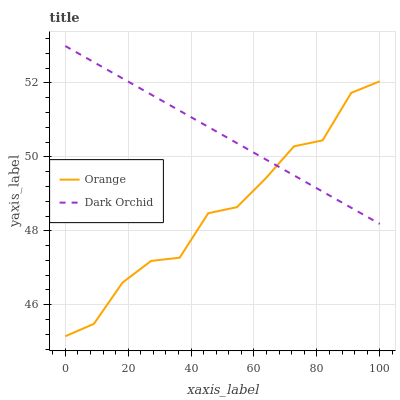Does Orange have the minimum area under the curve?
Answer yes or no. Yes. Does Dark Orchid have the maximum area under the curve?
Answer yes or no. Yes. Does Dark Orchid have the minimum area under the curve?
Answer yes or no. No. Is Dark Orchid the smoothest?
Answer yes or no. Yes. Is Orange the roughest?
Answer yes or no. Yes. Is Dark Orchid the roughest?
Answer yes or no. No. Does Dark Orchid have the lowest value?
Answer yes or no. No. Does Dark Orchid have the highest value?
Answer yes or no. Yes. Does Orange intersect Dark Orchid?
Answer yes or no. Yes. Is Orange less than Dark Orchid?
Answer yes or no. No. Is Orange greater than Dark Orchid?
Answer yes or no. No. 